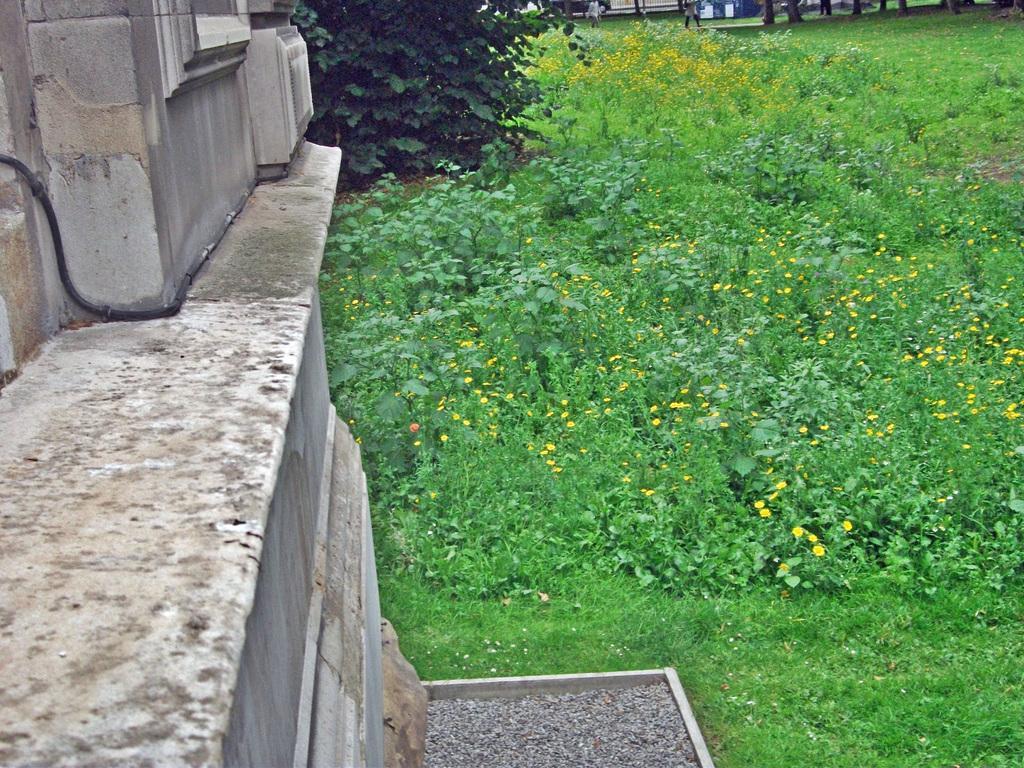Can you describe this image briefly? Left side of the image there is a wall. Beside it there is a tree. Right side there are few plants having flowers. Plants are on the grassland. Top of the image few persons are walking on the path. Few tree trunks are on the grassland. 